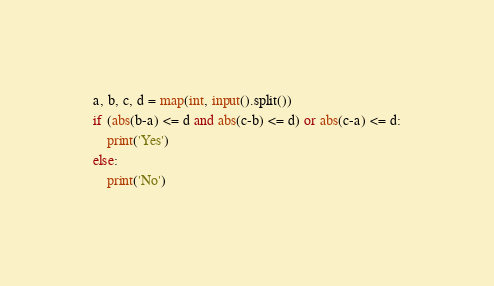<code> <loc_0><loc_0><loc_500><loc_500><_Python_>a, b, c, d = map(int, input().split())
if (abs(b-a) <= d and abs(c-b) <= d) or abs(c-a) <= d:
    print('Yes')
else:
    print('No')</code> 